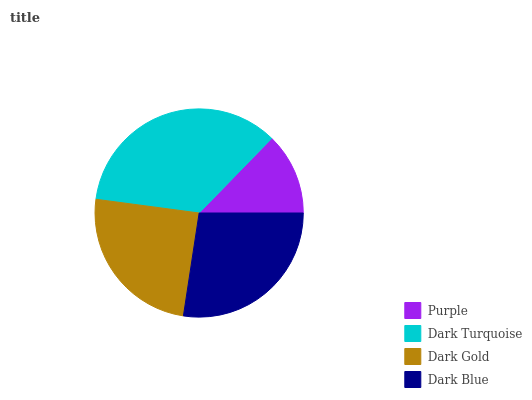Is Purple the minimum?
Answer yes or no. Yes. Is Dark Turquoise the maximum?
Answer yes or no. Yes. Is Dark Gold the minimum?
Answer yes or no. No. Is Dark Gold the maximum?
Answer yes or no. No. Is Dark Turquoise greater than Dark Gold?
Answer yes or no. Yes. Is Dark Gold less than Dark Turquoise?
Answer yes or no. Yes. Is Dark Gold greater than Dark Turquoise?
Answer yes or no. No. Is Dark Turquoise less than Dark Gold?
Answer yes or no. No. Is Dark Blue the high median?
Answer yes or no. Yes. Is Dark Gold the low median?
Answer yes or no. Yes. Is Purple the high median?
Answer yes or no. No. Is Purple the low median?
Answer yes or no. No. 